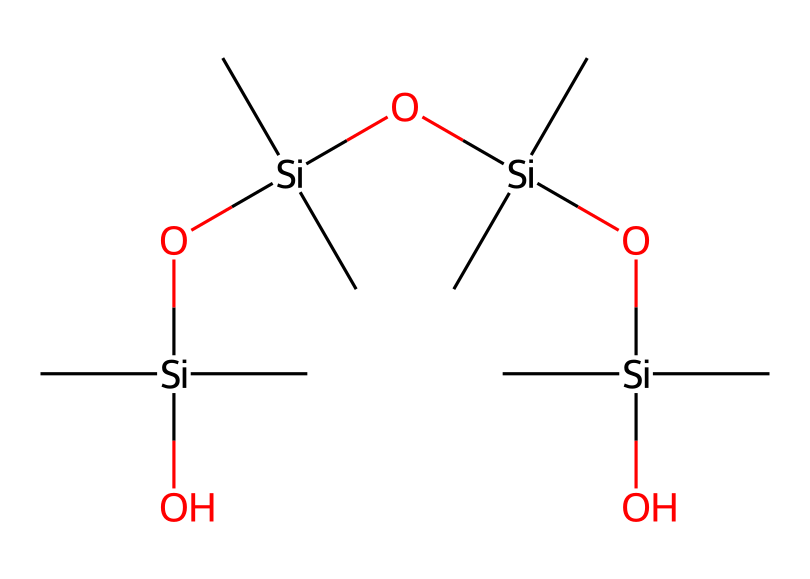How many silicon atoms are present in this chemical? The SMILES representation shows multiple repeating units. Count the 'Si' symbols; each represents a silicon atom. In this chemical, there are four 'Si' atoms in total.
Answer: four What type of chemical bond connects the silicon and oxygen in the siloxane structure? In siloxane compounds like this one, silicon ('Si') is bonded to oxygen ('O') by a covalent bond. The repeating structure also indicates these bonds are part of a siloxane linkage (Si-O).
Answer: covalent bond How many oxygen atoms are in this chemical? Counting the 'O' symbols in the SMILES notation reveals that there are five oxygen atoms present within the entire structure.
Answer: five What is the core repeating unit represented in this molecule? The central segment of the molecule shows a pattern comprising alternating silicon and oxygen atoms. This repeating unit is characteristic of siloxanes. Specifically, it can be designated as a siloxane unit (Si-O).
Answer: siloxane unit Which functional group can be identified in the chemical? The presence of the hydroxyl group ('O[Si](C)(C)') indicates that this chemical contains hydroxyl functionalities associated with siloxanes, providing it reactive properties.
Answer: hydroxyl group How many carbon atoms are there in the chemical? By counting the 'C' symbols in the SMILES representation, we find that there are twelve carbon atoms present in total.
Answer: twelve What property of siloxane compounds contributes to their use in turf treatments? Siloxane compounds exhibit water repellency due to their hydrophobic nature resulting from the silicon-oxygen backbone; this property helps maintain turf performance by repelling water and reducing the formation of mud.
Answer: water repellency 